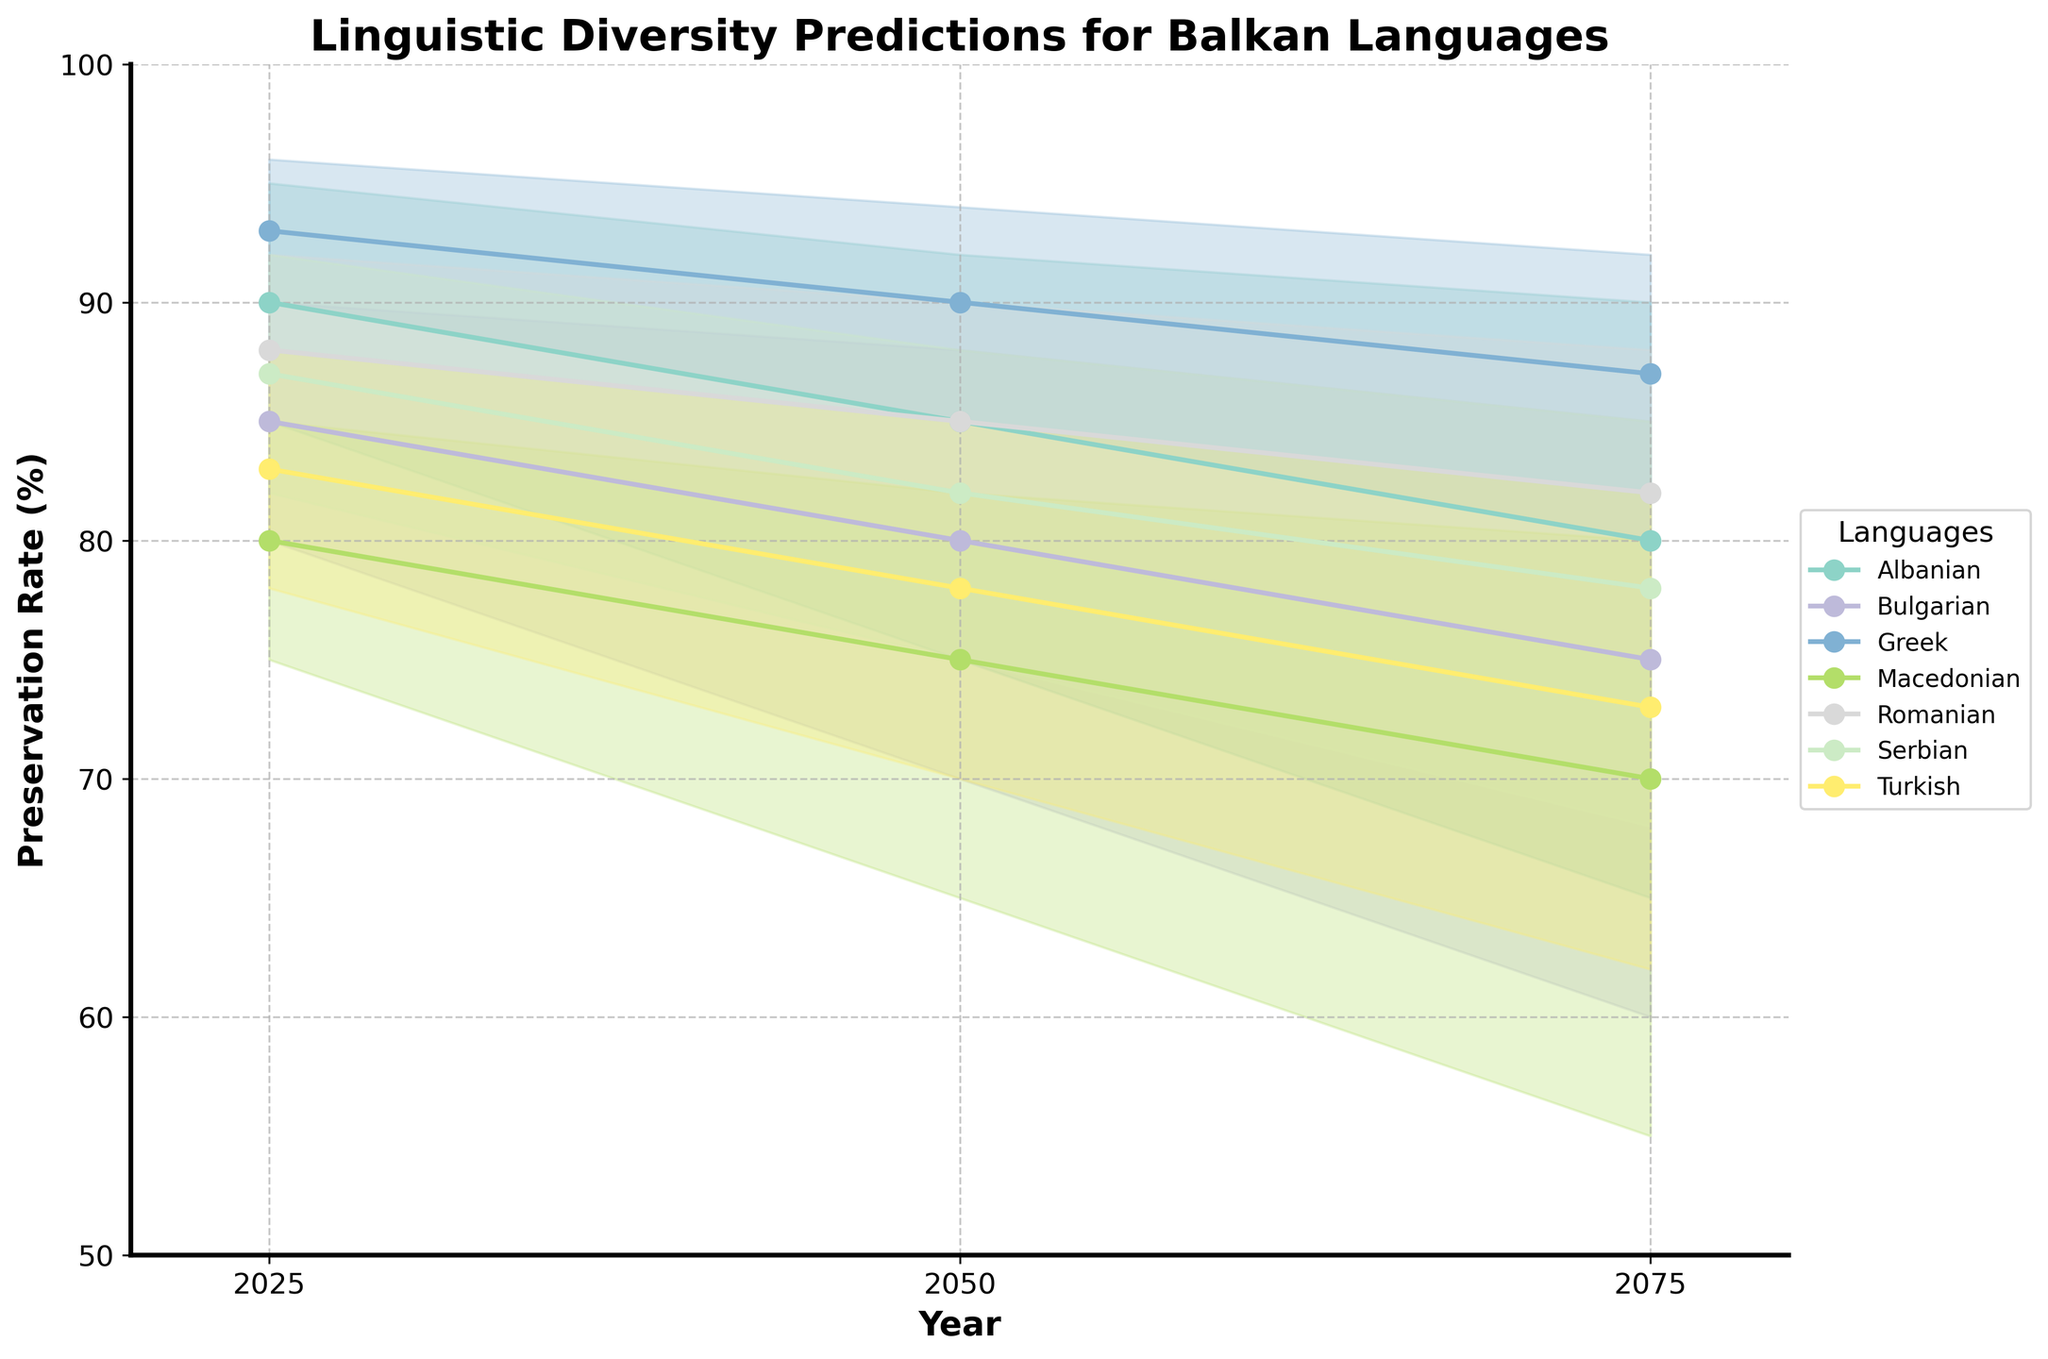What is the title of the chart? The title is displayed at the top of the chart and summarizes the content being shown, which is predictions of linguistic diversity for Balkan languages.
Answer: Linguistic Diversity Predictions for Balkan Languages What are the axis labels used in the figure? The labels on the horizontal and vertical axes describe the data dimensions being plotted: the year and the preservation rate, respectively.
Answer: Year (x-axis) and Preservation Rate (%) (y-axis) Which language shows the highest preservation rate in 2025 for the medium prediction? By visually inspecting the medium prediction lines for each language in 2025, we find the one with the highest value.
Answer: Greek What are the preservation rate ranges for Albanian in 2075? Check the filled area representing the low and high preservation rates for Albanian in 2075. The lower boundary shows the low rate, and the upper boundary shows the high rate.
Answer: 65% to 90% Which language experiences the largest drop in the medium preservation rate from 2025 to 2075? Calculate the difference in medium preservation rates between 2025 and 2075 for each language and identify the maximum drop.
Answer: Bulgarian What is the average medium preservation rate for Greek across all years shown? Add the medium preservation rates for Greek in 2025, 2050, and 2075, then divide by the number of years (3).
Answer: (93 + 90 + 87) / 3 = 90% Between which years does Macedonian's low preservation rate fall below 60%? Check the low preservation rates plotted over the years for Macedonian to find the first occurrence and subsequent period below 60%.
Answer: Between 2050 and 2075 Which three languages have the narrowest range between high and low preservation rates in 2025? Evaluate the difference between high and low preservation rates for all languages in 2025, and then list the three with the smallest range.
Answer: Greek, Romanian, Serbian How does the preservation rate trend for Turkish from 2025 to 2075 compare with that of Macedonian? Visually compare the lines and the filled areas for Turkish and Macedonian across the three time points to understand their trends.
Answer: Turkish decreases steadily and slightly whereas Macedonian shows a more significant decrease What is the preservation rate range for Romanian in 2050 based on the high and low predictions? Identify the high and low boundary values for Romanian in 2050 on the chart.
Answer: 80% to 90% 